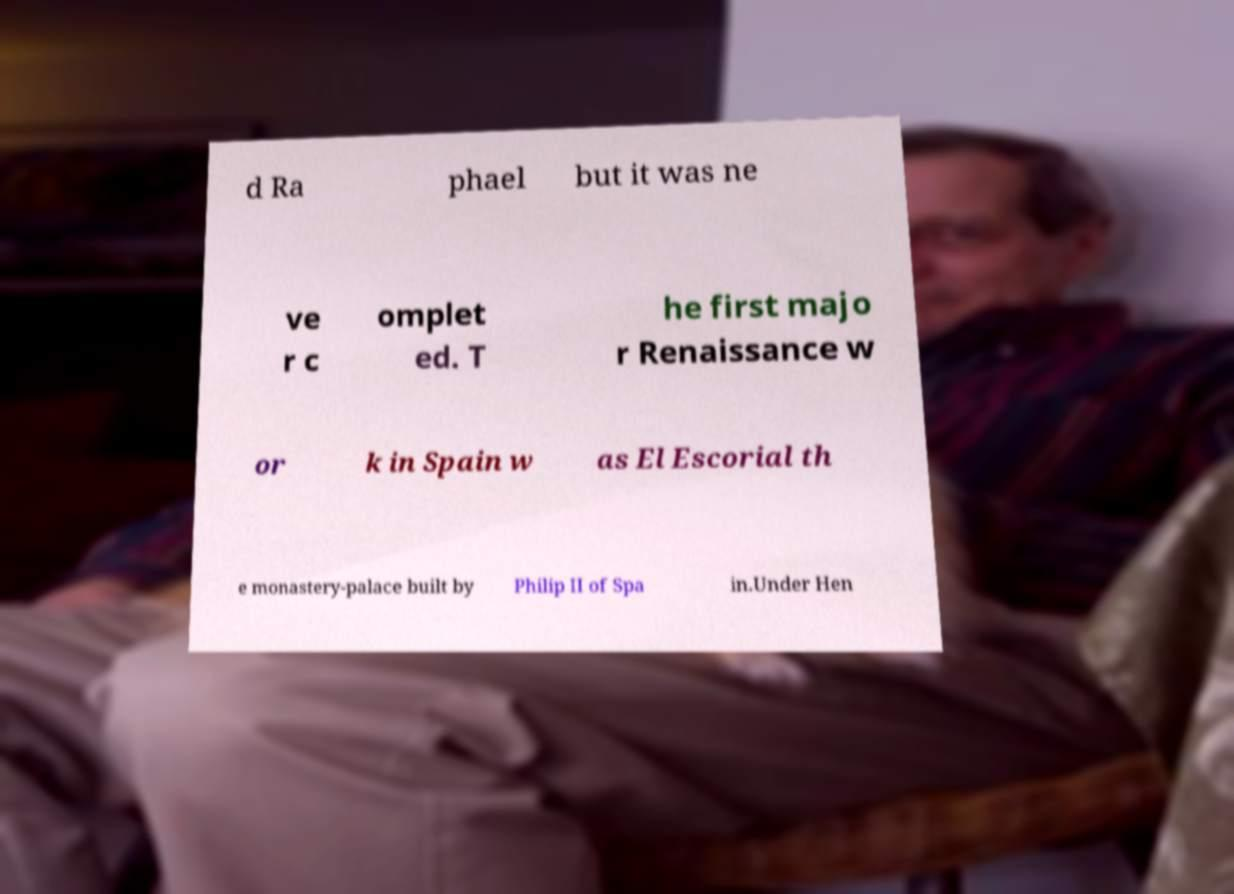What messages or text are displayed in this image? I need them in a readable, typed format. d Ra phael but it was ne ve r c omplet ed. T he first majo r Renaissance w or k in Spain w as El Escorial th e monastery-palace built by Philip II of Spa in.Under Hen 